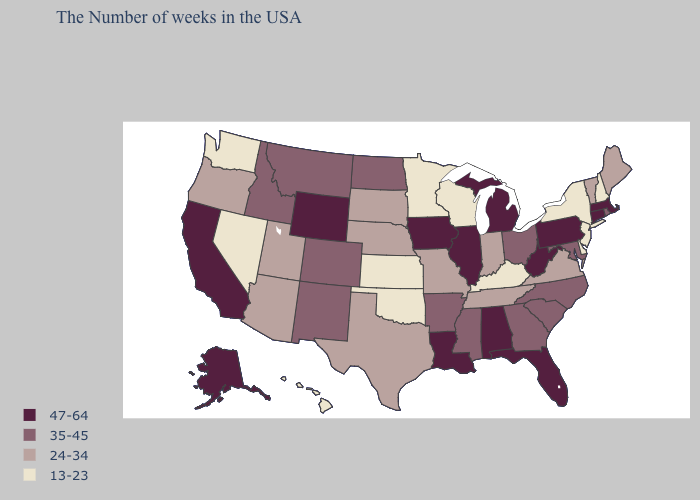Does the first symbol in the legend represent the smallest category?
Short answer required. No. Does the map have missing data?
Be succinct. No. Among the states that border Montana , which have the lowest value?
Answer briefly. South Dakota. Name the states that have a value in the range 13-23?
Short answer required. New Hampshire, New York, New Jersey, Delaware, Kentucky, Wisconsin, Minnesota, Kansas, Oklahoma, Nevada, Washington, Hawaii. What is the value of Washington?
Keep it brief. 13-23. Does Nevada have the lowest value in the USA?
Short answer required. Yes. Does Indiana have the lowest value in the USA?
Write a very short answer. No. What is the highest value in the West ?
Write a very short answer. 47-64. Among the states that border Montana , does Wyoming have the highest value?
Write a very short answer. Yes. What is the lowest value in states that border Pennsylvania?
Answer briefly. 13-23. What is the lowest value in states that border New Mexico?
Concise answer only. 13-23. Name the states that have a value in the range 13-23?
Short answer required. New Hampshire, New York, New Jersey, Delaware, Kentucky, Wisconsin, Minnesota, Kansas, Oklahoma, Nevada, Washington, Hawaii. What is the lowest value in states that border Georgia?
Answer briefly. 24-34. How many symbols are there in the legend?
Be succinct. 4. Is the legend a continuous bar?
Keep it brief. No. 